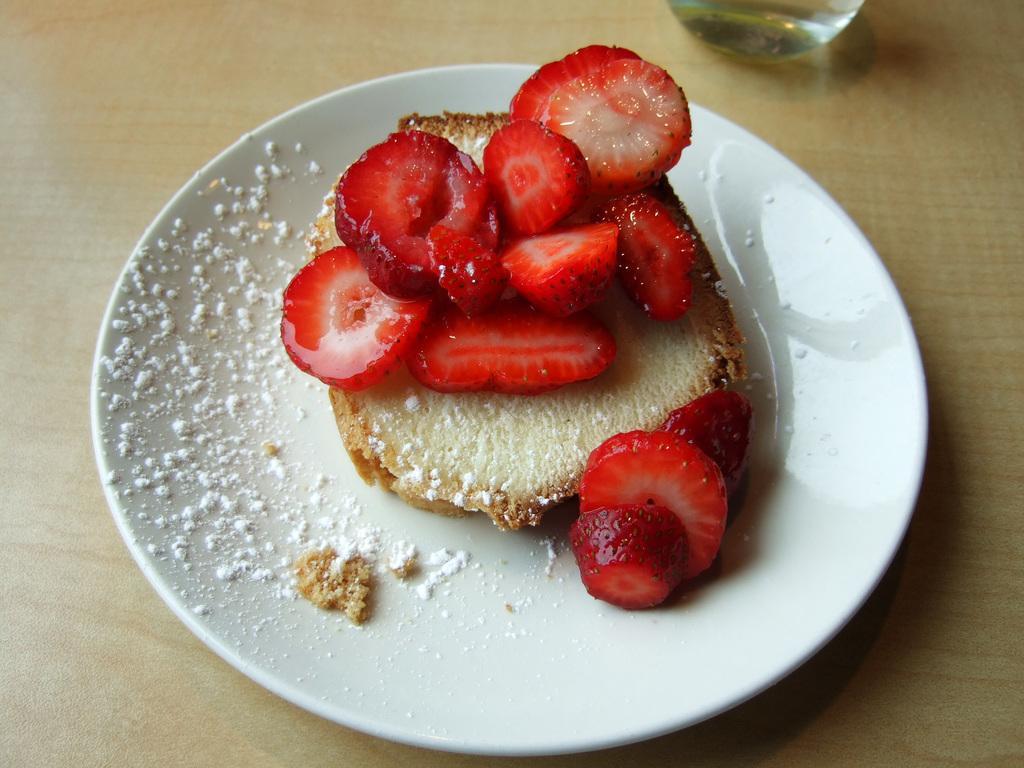In one or two sentences, can you explain what this image depicts? In this image I can see strawberry and bread piece on the white color plate. The plate is on the brown color table. 